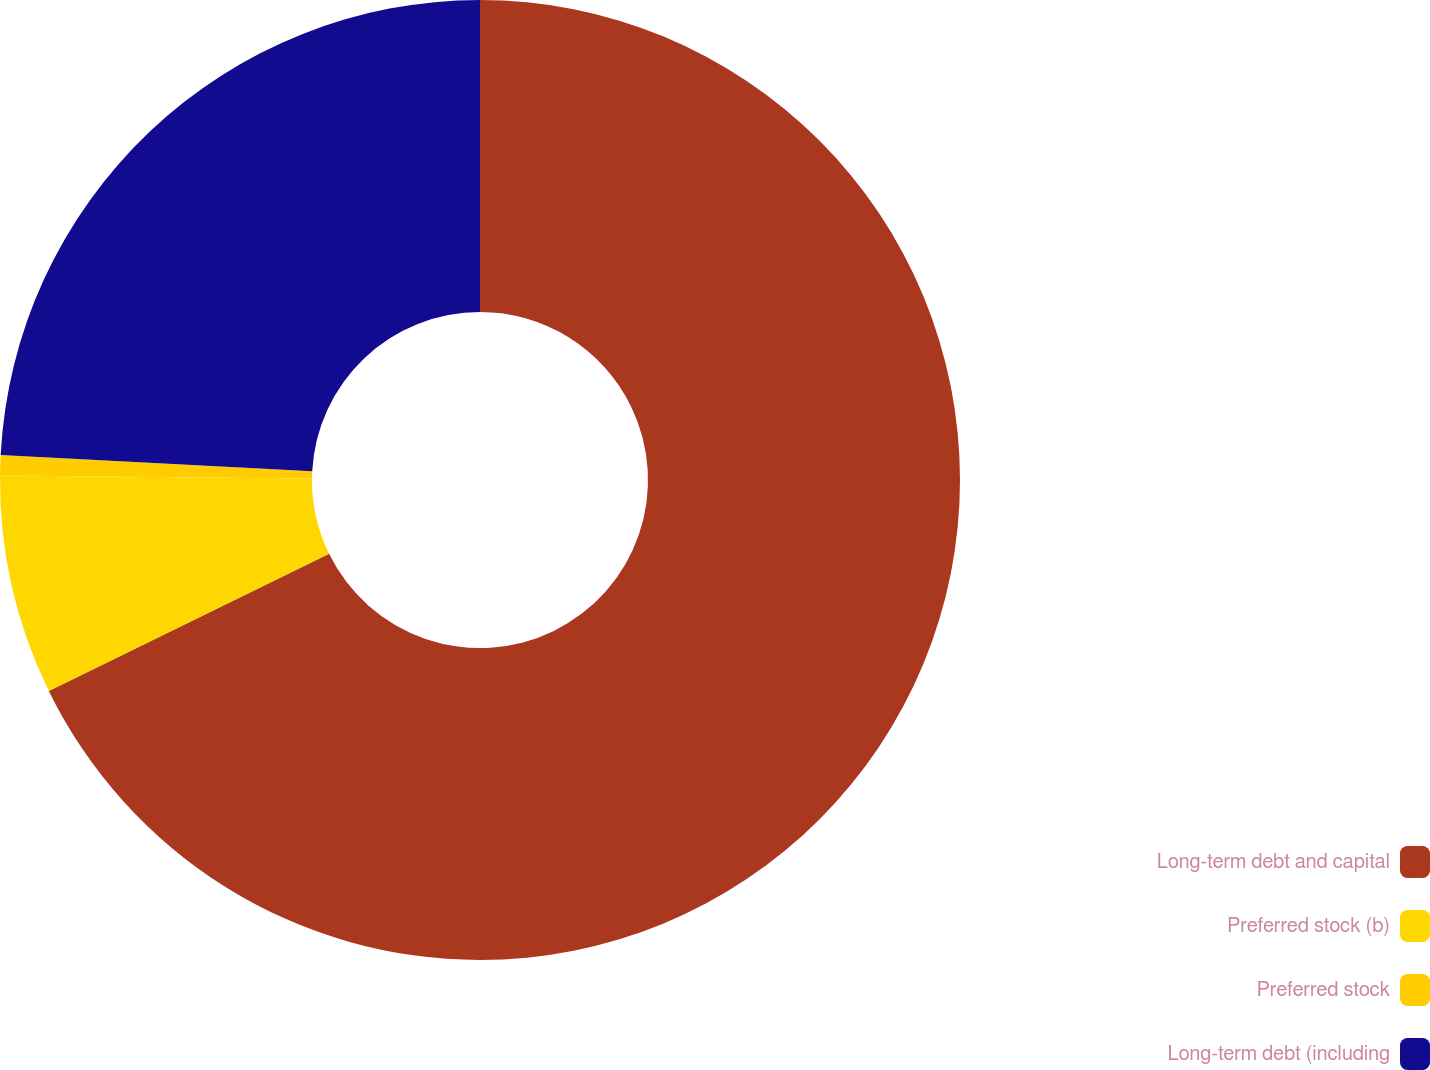<chart> <loc_0><loc_0><loc_500><loc_500><pie_chart><fcel>Long-term debt and capital<fcel>Preferred stock (b)<fcel>Preferred stock<fcel>Long-term debt (including<nl><fcel>67.76%<fcel>7.39%<fcel>0.68%<fcel>24.17%<nl></chart> 